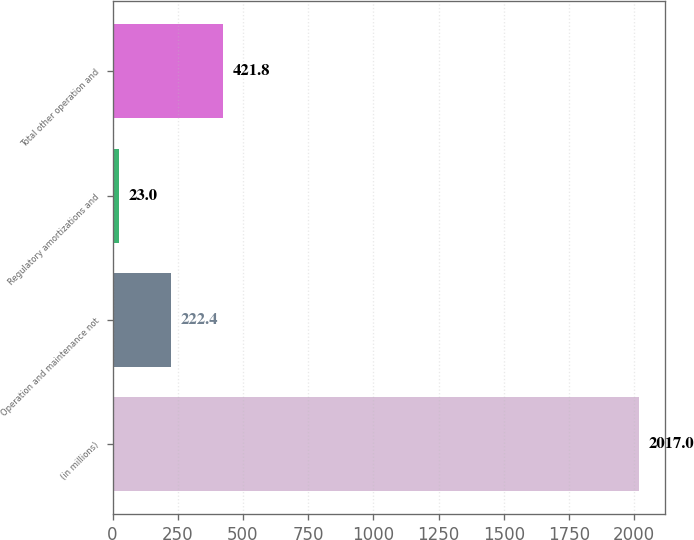Convert chart. <chart><loc_0><loc_0><loc_500><loc_500><bar_chart><fcel>(in millions)<fcel>Operation and maintenance not<fcel>Regulatory amortizations and<fcel>Total other operation and<nl><fcel>2017<fcel>222.4<fcel>23<fcel>421.8<nl></chart> 